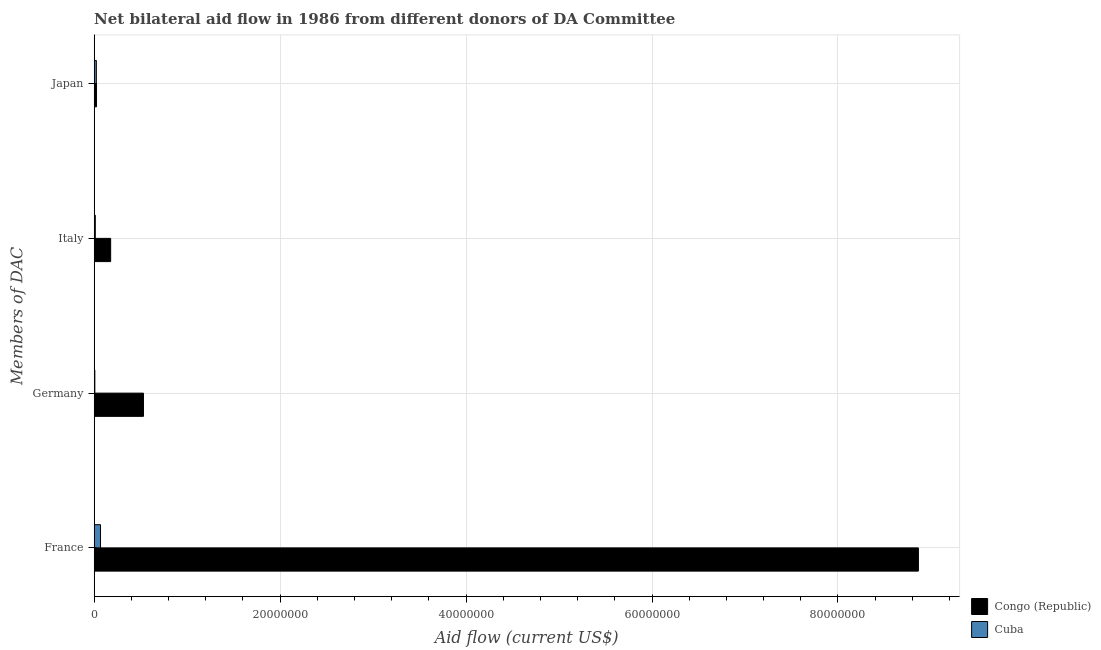How many different coloured bars are there?
Provide a short and direct response. 2. How many groups of bars are there?
Offer a very short reply. 4. Are the number of bars on each tick of the Y-axis equal?
Give a very brief answer. Yes. What is the amount of aid given by italy in Congo (Republic)?
Ensure brevity in your answer.  1.77e+06. Across all countries, what is the maximum amount of aid given by japan?
Your response must be concise. 2.50e+05. Across all countries, what is the minimum amount of aid given by germany?
Make the answer very short. 7.00e+04. In which country was the amount of aid given by germany maximum?
Your response must be concise. Congo (Republic). In which country was the amount of aid given by japan minimum?
Provide a succinct answer. Cuba. What is the total amount of aid given by italy in the graph?
Offer a terse response. 1.89e+06. What is the difference between the amount of aid given by japan in Cuba and that in Congo (Republic)?
Make the answer very short. -2.00e+04. What is the difference between the amount of aid given by japan in Cuba and the amount of aid given by france in Congo (Republic)?
Ensure brevity in your answer.  -8.84e+07. What is the average amount of aid given by germany per country?
Keep it short and to the point. 2.68e+06. What is the difference between the amount of aid given by germany and amount of aid given by italy in Congo (Republic)?
Your answer should be very brief. 3.53e+06. What is the ratio of the amount of aid given by italy in Cuba to that in Congo (Republic)?
Your answer should be compact. 0.07. Is the amount of aid given by italy in Congo (Republic) less than that in Cuba?
Give a very brief answer. No. What is the difference between the highest and the second highest amount of aid given by germany?
Make the answer very short. 5.23e+06. What is the difference between the highest and the lowest amount of aid given by japan?
Provide a succinct answer. 2.00e+04. Is the sum of the amount of aid given by germany in Congo (Republic) and Cuba greater than the maximum amount of aid given by italy across all countries?
Offer a terse response. Yes. What does the 1st bar from the top in France represents?
Provide a short and direct response. Cuba. What does the 1st bar from the bottom in Japan represents?
Keep it short and to the point. Congo (Republic). Does the graph contain any zero values?
Offer a very short reply. No. How are the legend labels stacked?
Give a very brief answer. Vertical. What is the title of the graph?
Keep it short and to the point. Net bilateral aid flow in 1986 from different donors of DA Committee. Does "Low & middle income" appear as one of the legend labels in the graph?
Make the answer very short. No. What is the label or title of the Y-axis?
Provide a short and direct response. Members of DAC. What is the Aid flow (current US$) of Congo (Republic) in France?
Give a very brief answer. 8.86e+07. What is the Aid flow (current US$) in Cuba in France?
Ensure brevity in your answer.  6.80e+05. What is the Aid flow (current US$) of Congo (Republic) in Germany?
Give a very brief answer. 5.30e+06. What is the Aid flow (current US$) of Congo (Republic) in Italy?
Ensure brevity in your answer.  1.77e+06. What is the Aid flow (current US$) of Congo (Republic) in Japan?
Offer a very short reply. 2.50e+05. Across all Members of DAC, what is the maximum Aid flow (current US$) in Congo (Republic)?
Keep it short and to the point. 8.86e+07. Across all Members of DAC, what is the maximum Aid flow (current US$) in Cuba?
Offer a very short reply. 6.80e+05. Across all Members of DAC, what is the minimum Aid flow (current US$) of Congo (Republic)?
Offer a terse response. 2.50e+05. Across all Members of DAC, what is the minimum Aid flow (current US$) of Cuba?
Ensure brevity in your answer.  7.00e+04. What is the total Aid flow (current US$) in Congo (Republic) in the graph?
Offer a terse response. 9.60e+07. What is the total Aid flow (current US$) in Cuba in the graph?
Make the answer very short. 1.10e+06. What is the difference between the Aid flow (current US$) of Congo (Republic) in France and that in Germany?
Offer a terse response. 8.34e+07. What is the difference between the Aid flow (current US$) of Congo (Republic) in France and that in Italy?
Keep it short and to the point. 8.69e+07. What is the difference between the Aid flow (current US$) of Cuba in France and that in Italy?
Your response must be concise. 5.60e+05. What is the difference between the Aid flow (current US$) of Congo (Republic) in France and that in Japan?
Provide a succinct answer. 8.84e+07. What is the difference between the Aid flow (current US$) in Cuba in France and that in Japan?
Give a very brief answer. 4.50e+05. What is the difference between the Aid flow (current US$) of Congo (Republic) in Germany and that in Italy?
Ensure brevity in your answer.  3.53e+06. What is the difference between the Aid flow (current US$) in Cuba in Germany and that in Italy?
Your response must be concise. -5.00e+04. What is the difference between the Aid flow (current US$) of Congo (Republic) in Germany and that in Japan?
Keep it short and to the point. 5.05e+06. What is the difference between the Aid flow (current US$) of Congo (Republic) in Italy and that in Japan?
Make the answer very short. 1.52e+06. What is the difference between the Aid flow (current US$) in Congo (Republic) in France and the Aid flow (current US$) in Cuba in Germany?
Provide a succinct answer. 8.86e+07. What is the difference between the Aid flow (current US$) of Congo (Republic) in France and the Aid flow (current US$) of Cuba in Italy?
Your answer should be compact. 8.85e+07. What is the difference between the Aid flow (current US$) in Congo (Republic) in France and the Aid flow (current US$) in Cuba in Japan?
Your answer should be very brief. 8.84e+07. What is the difference between the Aid flow (current US$) of Congo (Republic) in Germany and the Aid flow (current US$) of Cuba in Italy?
Provide a succinct answer. 5.18e+06. What is the difference between the Aid flow (current US$) in Congo (Republic) in Germany and the Aid flow (current US$) in Cuba in Japan?
Your response must be concise. 5.07e+06. What is the difference between the Aid flow (current US$) of Congo (Republic) in Italy and the Aid flow (current US$) of Cuba in Japan?
Give a very brief answer. 1.54e+06. What is the average Aid flow (current US$) of Congo (Republic) per Members of DAC?
Your answer should be compact. 2.40e+07. What is the average Aid flow (current US$) in Cuba per Members of DAC?
Make the answer very short. 2.75e+05. What is the difference between the Aid flow (current US$) in Congo (Republic) and Aid flow (current US$) in Cuba in France?
Keep it short and to the point. 8.80e+07. What is the difference between the Aid flow (current US$) of Congo (Republic) and Aid flow (current US$) of Cuba in Germany?
Your answer should be very brief. 5.23e+06. What is the difference between the Aid flow (current US$) of Congo (Republic) and Aid flow (current US$) of Cuba in Italy?
Give a very brief answer. 1.65e+06. What is the difference between the Aid flow (current US$) in Congo (Republic) and Aid flow (current US$) in Cuba in Japan?
Your answer should be compact. 2.00e+04. What is the ratio of the Aid flow (current US$) in Congo (Republic) in France to that in Germany?
Your answer should be compact. 16.73. What is the ratio of the Aid flow (current US$) in Cuba in France to that in Germany?
Give a very brief answer. 9.71. What is the ratio of the Aid flow (current US$) in Congo (Republic) in France to that in Italy?
Make the answer very short. 50.08. What is the ratio of the Aid flow (current US$) of Cuba in France to that in Italy?
Offer a terse response. 5.67. What is the ratio of the Aid flow (current US$) of Congo (Republic) in France to that in Japan?
Provide a short and direct response. 354.6. What is the ratio of the Aid flow (current US$) of Cuba in France to that in Japan?
Your answer should be compact. 2.96. What is the ratio of the Aid flow (current US$) of Congo (Republic) in Germany to that in Italy?
Offer a very short reply. 2.99. What is the ratio of the Aid flow (current US$) in Cuba in Germany to that in Italy?
Provide a short and direct response. 0.58. What is the ratio of the Aid flow (current US$) in Congo (Republic) in Germany to that in Japan?
Your response must be concise. 21.2. What is the ratio of the Aid flow (current US$) in Cuba in Germany to that in Japan?
Your answer should be compact. 0.3. What is the ratio of the Aid flow (current US$) in Congo (Republic) in Italy to that in Japan?
Offer a terse response. 7.08. What is the ratio of the Aid flow (current US$) of Cuba in Italy to that in Japan?
Provide a succinct answer. 0.52. What is the difference between the highest and the second highest Aid flow (current US$) in Congo (Republic)?
Your answer should be very brief. 8.34e+07. What is the difference between the highest and the lowest Aid flow (current US$) in Congo (Republic)?
Ensure brevity in your answer.  8.84e+07. What is the difference between the highest and the lowest Aid flow (current US$) in Cuba?
Your answer should be compact. 6.10e+05. 